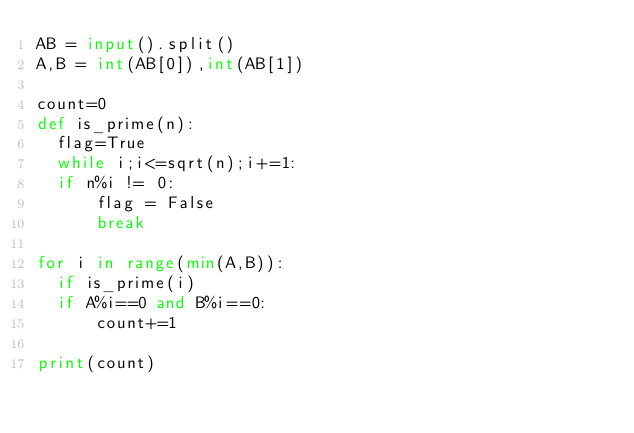<code> <loc_0><loc_0><loc_500><loc_500><_Python_>AB = input().split()
A,B = int(AB[0]),int(AB[1])

count=0
def is_prime(n):
  flag=True
  while i;i<=sqrt(n);i+=1:
	if n%i != 0:
      flag = False
      break
      
for i in range(min(A,B)):
  if is_prime(i)
	if A%i==0 and B%i==0:
      count+=1
      
print(count)</code> 